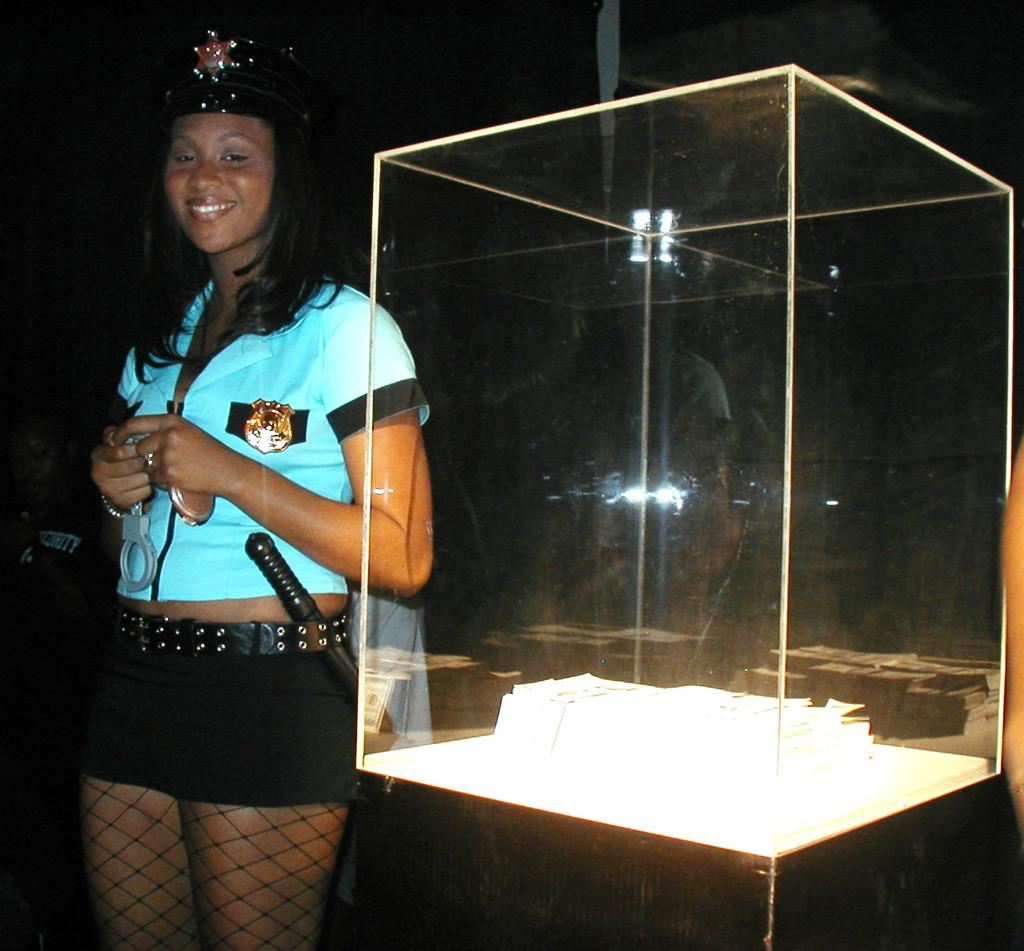Who is present in the image? There is a woman in the image. What is the woman wearing on her head? The woman is wearing a cap. What is the woman doing in the image? The woman is standing and smiling. What is the unusual object in the image? There is a handcuff in the image. What is the transparent structure in the image? There is a glass box in the image. Can you describe the background of the image? The background of the image is dark. What is this is a trick question, but what is the name of the country where the record was set? This is an absurd question, as there is no reference to a record or a country in the image. 